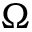<formula> <loc_0><loc_0><loc_500><loc_500>\Omega</formula> 